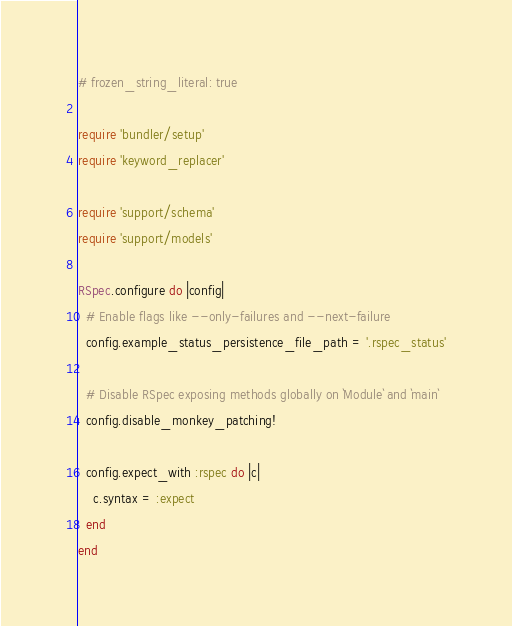<code> <loc_0><loc_0><loc_500><loc_500><_Ruby_># frozen_string_literal: true

require 'bundler/setup'
require 'keyword_replacer'

require 'support/schema'
require 'support/models'

RSpec.configure do |config|
  # Enable flags like --only-failures and --next-failure
  config.example_status_persistence_file_path = '.rspec_status'

  # Disable RSpec exposing methods globally on `Module` and `main`
  config.disable_monkey_patching!

  config.expect_with :rspec do |c|
    c.syntax = :expect
  end
end
</code> 